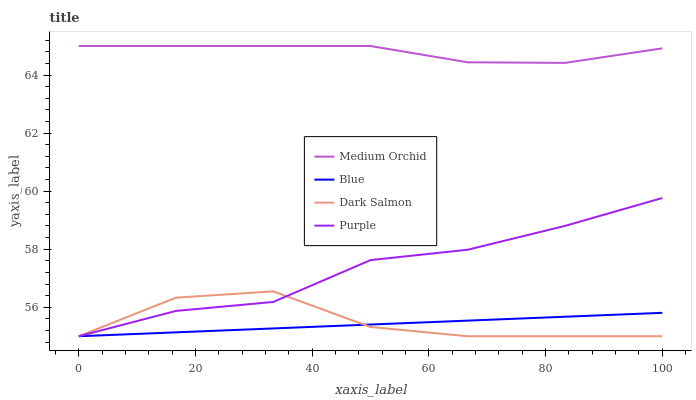Does Blue have the minimum area under the curve?
Answer yes or no. Yes. Does Medium Orchid have the maximum area under the curve?
Answer yes or no. Yes. Does Purple have the minimum area under the curve?
Answer yes or no. No. Does Purple have the maximum area under the curve?
Answer yes or no. No. Is Blue the smoothest?
Answer yes or no. Yes. Is Dark Salmon the roughest?
Answer yes or no. Yes. Is Purple the smoothest?
Answer yes or no. No. Is Purple the roughest?
Answer yes or no. No. Does Medium Orchid have the lowest value?
Answer yes or no. No. Does Purple have the highest value?
Answer yes or no. No. Is Blue less than Medium Orchid?
Answer yes or no. Yes. Is Medium Orchid greater than Purple?
Answer yes or no. Yes. Does Blue intersect Medium Orchid?
Answer yes or no. No. 